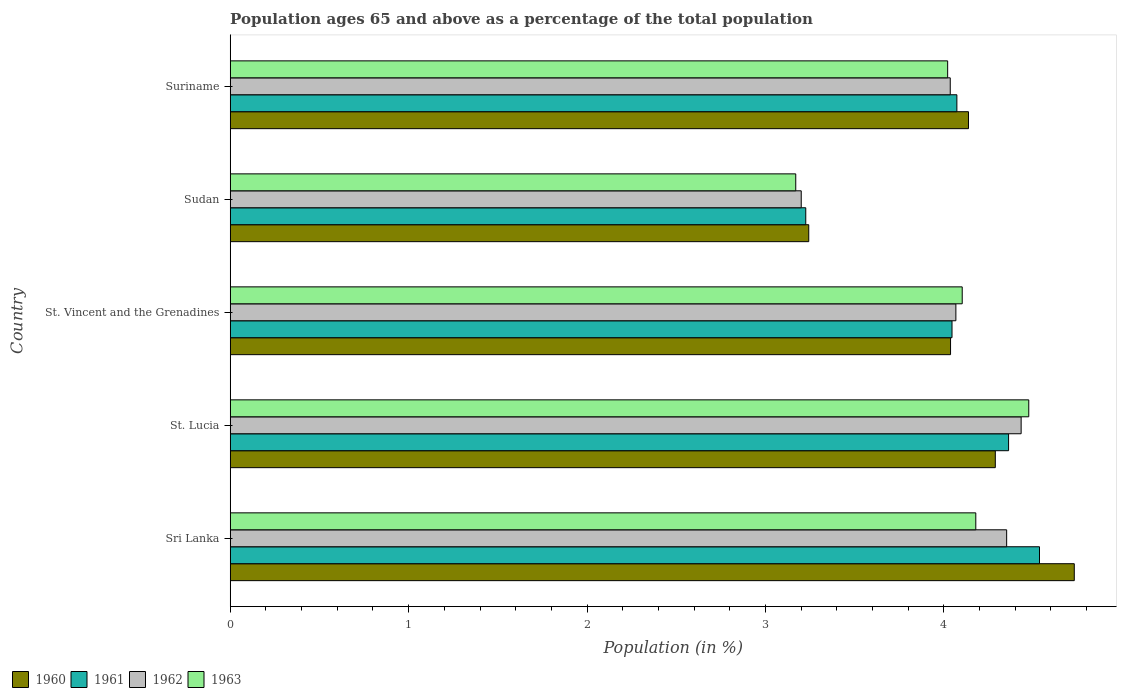Are the number of bars per tick equal to the number of legend labels?
Offer a very short reply. Yes. How many bars are there on the 5th tick from the bottom?
Keep it short and to the point. 4. What is the label of the 4th group of bars from the top?
Provide a short and direct response. St. Lucia. In how many cases, is the number of bars for a given country not equal to the number of legend labels?
Your response must be concise. 0. What is the percentage of the population ages 65 and above in 1963 in Sri Lanka?
Offer a very short reply. 4.18. Across all countries, what is the maximum percentage of the population ages 65 and above in 1962?
Ensure brevity in your answer.  4.43. Across all countries, what is the minimum percentage of the population ages 65 and above in 1961?
Provide a short and direct response. 3.23. In which country was the percentage of the population ages 65 and above in 1960 maximum?
Provide a short and direct response. Sri Lanka. In which country was the percentage of the population ages 65 and above in 1963 minimum?
Offer a very short reply. Sudan. What is the total percentage of the population ages 65 and above in 1960 in the graph?
Your answer should be very brief. 20.44. What is the difference between the percentage of the population ages 65 and above in 1962 in Sri Lanka and that in St. Lucia?
Offer a very short reply. -0.08. What is the difference between the percentage of the population ages 65 and above in 1962 in St. Vincent and the Grenadines and the percentage of the population ages 65 and above in 1961 in Sri Lanka?
Provide a succinct answer. -0.47. What is the average percentage of the population ages 65 and above in 1962 per country?
Offer a very short reply. 4.02. What is the difference between the percentage of the population ages 65 and above in 1961 and percentage of the population ages 65 and above in 1963 in Sudan?
Offer a terse response. 0.06. What is the ratio of the percentage of the population ages 65 and above in 1960 in St. Vincent and the Grenadines to that in Suriname?
Make the answer very short. 0.98. Is the difference between the percentage of the population ages 65 and above in 1961 in St. Lucia and Sudan greater than the difference between the percentage of the population ages 65 and above in 1963 in St. Lucia and Sudan?
Provide a succinct answer. No. What is the difference between the highest and the second highest percentage of the population ages 65 and above in 1962?
Your answer should be very brief. 0.08. What is the difference between the highest and the lowest percentage of the population ages 65 and above in 1961?
Ensure brevity in your answer.  1.31. In how many countries, is the percentage of the population ages 65 and above in 1961 greater than the average percentage of the population ages 65 and above in 1961 taken over all countries?
Your answer should be very brief. 3. Is the sum of the percentage of the population ages 65 and above in 1962 in St. Vincent and the Grenadines and Suriname greater than the maximum percentage of the population ages 65 and above in 1963 across all countries?
Provide a succinct answer. Yes. What does the 1st bar from the bottom in Suriname represents?
Your answer should be very brief. 1960. How many countries are there in the graph?
Keep it short and to the point. 5. What is the difference between two consecutive major ticks on the X-axis?
Your response must be concise. 1. Are the values on the major ticks of X-axis written in scientific E-notation?
Your answer should be compact. No. Does the graph contain any zero values?
Provide a short and direct response. No. Does the graph contain grids?
Keep it short and to the point. No. What is the title of the graph?
Your answer should be compact. Population ages 65 and above as a percentage of the total population. What is the label or title of the X-axis?
Your answer should be compact. Population (in %). What is the label or title of the Y-axis?
Provide a succinct answer. Country. What is the Population (in %) in 1960 in Sri Lanka?
Make the answer very short. 4.73. What is the Population (in %) in 1961 in Sri Lanka?
Provide a succinct answer. 4.54. What is the Population (in %) of 1962 in Sri Lanka?
Give a very brief answer. 4.35. What is the Population (in %) in 1963 in Sri Lanka?
Make the answer very short. 4.18. What is the Population (in %) in 1960 in St. Lucia?
Offer a terse response. 4.29. What is the Population (in %) in 1961 in St. Lucia?
Give a very brief answer. 4.36. What is the Population (in %) of 1962 in St. Lucia?
Provide a succinct answer. 4.43. What is the Population (in %) of 1963 in St. Lucia?
Your answer should be very brief. 4.48. What is the Population (in %) of 1960 in St. Vincent and the Grenadines?
Provide a short and direct response. 4.04. What is the Population (in %) of 1961 in St. Vincent and the Grenadines?
Provide a short and direct response. 4.05. What is the Population (in %) in 1962 in St. Vincent and the Grenadines?
Provide a succinct answer. 4.07. What is the Population (in %) of 1963 in St. Vincent and the Grenadines?
Your response must be concise. 4.1. What is the Population (in %) in 1960 in Sudan?
Offer a terse response. 3.24. What is the Population (in %) in 1961 in Sudan?
Ensure brevity in your answer.  3.23. What is the Population (in %) in 1962 in Sudan?
Ensure brevity in your answer.  3.2. What is the Population (in %) of 1963 in Sudan?
Your answer should be compact. 3.17. What is the Population (in %) of 1960 in Suriname?
Give a very brief answer. 4.14. What is the Population (in %) of 1961 in Suriname?
Keep it short and to the point. 4.07. What is the Population (in %) of 1962 in Suriname?
Give a very brief answer. 4.04. What is the Population (in %) of 1963 in Suriname?
Your answer should be very brief. 4.02. Across all countries, what is the maximum Population (in %) in 1960?
Offer a terse response. 4.73. Across all countries, what is the maximum Population (in %) in 1961?
Your answer should be compact. 4.54. Across all countries, what is the maximum Population (in %) of 1962?
Provide a succinct answer. 4.43. Across all countries, what is the maximum Population (in %) in 1963?
Keep it short and to the point. 4.48. Across all countries, what is the minimum Population (in %) of 1960?
Provide a short and direct response. 3.24. Across all countries, what is the minimum Population (in %) in 1961?
Your answer should be compact. 3.23. Across all countries, what is the minimum Population (in %) in 1962?
Provide a succinct answer. 3.2. Across all countries, what is the minimum Population (in %) of 1963?
Give a very brief answer. 3.17. What is the total Population (in %) in 1960 in the graph?
Ensure brevity in your answer.  20.44. What is the total Population (in %) in 1961 in the graph?
Make the answer very short. 20.24. What is the total Population (in %) of 1962 in the graph?
Make the answer very short. 20.09. What is the total Population (in %) in 1963 in the graph?
Provide a short and direct response. 19.95. What is the difference between the Population (in %) in 1960 in Sri Lanka and that in St. Lucia?
Your answer should be very brief. 0.44. What is the difference between the Population (in %) in 1961 in Sri Lanka and that in St. Lucia?
Give a very brief answer. 0.17. What is the difference between the Population (in %) in 1962 in Sri Lanka and that in St. Lucia?
Your answer should be very brief. -0.08. What is the difference between the Population (in %) of 1963 in Sri Lanka and that in St. Lucia?
Your response must be concise. -0.3. What is the difference between the Population (in %) in 1960 in Sri Lanka and that in St. Vincent and the Grenadines?
Offer a terse response. 0.69. What is the difference between the Population (in %) in 1961 in Sri Lanka and that in St. Vincent and the Grenadines?
Offer a terse response. 0.49. What is the difference between the Population (in %) in 1962 in Sri Lanka and that in St. Vincent and the Grenadines?
Ensure brevity in your answer.  0.28. What is the difference between the Population (in %) of 1963 in Sri Lanka and that in St. Vincent and the Grenadines?
Offer a terse response. 0.08. What is the difference between the Population (in %) of 1960 in Sri Lanka and that in Sudan?
Offer a terse response. 1.49. What is the difference between the Population (in %) in 1961 in Sri Lanka and that in Sudan?
Make the answer very short. 1.31. What is the difference between the Population (in %) in 1962 in Sri Lanka and that in Sudan?
Ensure brevity in your answer.  1.15. What is the difference between the Population (in %) of 1963 in Sri Lanka and that in Sudan?
Keep it short and to the point. 1.01. What is the difference between the Population (in %) in 1960 in Sri Lanka and that in Suriname?
Your answer should be very brief. 0.59. What is the difference between the Population (in %) of 1961 in Sri Lanka and that in Suriname?
Provide a short and direct response. 0.46. What is the difference between the Population (in %) in 1962 in Sri Lanka and that in Suriname?
Keep it short and to the point. 0.32. What is the difference between the Population (in %) of 1963 in Sri Lanka and that in Suriname?
Your answer should be very brief. 0.16. What is the difference between the Population (in %) of 1960 in St. Lucia and that in St. Vincent and the Grenadines?
Provide a succinct answer. 0.25. What is the difference between the Population (in %) in 1961 in St. Lucia and that in St. Vincent and the Grenadines?
Provide a succinct answer. 0.32. What is the difference between the Population (in %) of 1962 in St. Lucia and that in St. Vincent and the Grenadines?
Your response must be concise. 0.37. What is the difference between the Population (in %) of 1963 in St. Lucia and that in St. Vincent and the Grenadines?
Keep it short and to the point. 0.37. What is the difference between the Population (in %) of 1960 in St. Lucia and that in Sudan?
Your answer should be very brief. 1.05. What is the difference between the Population (in %) in 1961 in St. Lucia and that in Sudan?
Your response must be concise. 1.14. What is the difference between the Population (in %) in 1962 in St. Lucia and that in Sudan?
Offer a terse response. 1.23. What is the difference between the Population (in %) of 1963 in St. Lucia and that in Sudan?
Offer a very short reply. 1.31. What is the difference between the Population (in %) in 1960 in St. Lucia and that in Suriname?
Your response must be concise. 0.15. What is the difference between the Population (in %) of 1961 in St. Lucia and that in Suriname?
Provide a succinct answer. 0.29. What is the difference between the Population (in %) of 1962 in St. Lucia and that in Suriname?
Your answer should be compact. 0.4. What is the difference between the Population (in %) of 1963 in St. Lucia and that in Suriname?
Provide a short and direct response. 0.45. What is the difference between the Population (in %) in 1960 in St. Vincent and the Grenadines and that in Sudan?
Ensure brevity in your answer.  0.79. What is the difference between the Population (in %) of 1961 in St. Vincent and the Grenadines and that in Sudan?
Offer a very short reply. 0.82. What is the difference between the Population (in %) of 1962 in St. Vincent and the Grenadines and that in Sudan?
Provide a short and direct response. 0.87. What is the difference between the Population (in %) of 1963 in St. Vincent and the Grenadines and that in Sudan?
Offer a very short reply. 0.93. What is the difference between the Population (in %) in 1960 in St. Vincent and the Grenadines and that in Suriname?
Offer a very short reply. -0.1. What is the difference between the Population (in %) in 1961 in St. Vincent and the Grenadines and that in Suriname?
Make the answer very short. -0.03. What is the difference between the Population (in %) in 1962 in St. Vincent and the Grenadines and that in Suriname?
Give a very brief answer. 0.03. What is the difference between the Population (in %) in 1963 in St. Vincent and the Grenadines and that in Suriname?
Your response must be concise. 0.08. What is the difference between the Population (in %) in 1960 in Sudan and that in Suriname?
Give a very brief answer. -0.9. What is the difference between the Population (in %) in 1961 in Sudan and that in Suriname?
Provide a succinct answer. -0.85. What is the difference between the Population (in %) in 1962 in Sudan and that in Suriname?
Your answer should be compact. -0.84. What is the difference between the Population (in %) of 1963 in Sudan and that in Suriname?
Your response must be concise. -0.85. What is the difference between the Population (in %) of 1960 in Sri Lanka and the Population (in %) of 1961 in St. Lucia?
Offer a terse response. 0.37. What is the difference between the Population (in %) of 1960 in Sri Lanka and the Population (in %) of 1962 in St. Lucia?
Provide a succinct answer. 0.3. What is the difference between the Population (in %) in 1960 in Sri Lanka and the Population (in %) in 1963 in St. Lucia?
Provide a short and direct response. 0.26. What is the difference between the Population (in %) in 1961 in Sri Lanka and the Population (in %) in 1962 in St. Lucia?
Your answer should be compact. 0.1. What is the difference between the Population (in %) of 1961 in Sri Lanka and the Population (in %) of 1963 in St. Lucia?
Your answer should be compact. 0.06. What is the difference between the Population (in %) in 1962 in Sri Lanka and the Population (in %) in 1963 in St. Lucia?
Make the answer very short. -0.12. What is the difference between the Population (in %) of 1960 in Sri Lanka and the Population (in %) of 1961 in St. Vincent and the Grenadines?
Your response must be concise. 0.69. What is the difference between the Population (in %) in 1960 in Sri Lanka and the Population (in %) in 1962 in St. Vincent and the Grenadines?
Provide a succinct answer. 0.66. What is the difference between the Population (in %) of 1960 in Sri Lanka and the Population (in %) of 1963 in St. Vincent and the Grenadines?
Provide a succinct answer. 0.63. What is the difference between the Population (in %) in 1961 in Sri Lanka and the Population (in %) in 1962 in St. Vincent and the Grenadines?
Ensure brevity in your answer.  0.47. What is the difference between the Population (in %) in 1961 in Sri Lanka and the Population (in %) in 1963 in St. Vincent and the Grenadines?
Offer a very short reply. 0.43. What is the difference between the Population (in %) in 1962 in Sri Lanka and the Population (in %) in 1963 in St. Vincent and the Grenadines?
Offer a very short reply. 0.25. What is the difference between the Population (in %) in 1960 in Sri Lanka and the Population (in %) in 1961 in Sudan?
Provide a short and direct response. 1.5. What is the difference between the Population (in %) in 1960 in Sri Lanka and the Population (in %) in 1962 in Sudan?
Make the answer very short. 1.53. What is the difference between the Population (in %) in 1960 in Sri Lanka and the Population (in %) in 1963 in Sudan?
Provide a succinct answer. 1.56. What is the difference between the Population (in %) of 1961 in Sri Lanka and the Population (in %) of 1962 in Sudan?
Provide a succinct answer. 1.34. What is the difference between the Population (in %) of 1961 in Sri Lanka and the Population (in %) of 1963 in Sudan?
Your response must be concise. 1.37. What is the difference between the Population (in %) in 1962 in Sri Lanka and the Population (in %) in 1963 in Sudan?
Your response must be concise. 1.18. What is the difference between the Population (in %) of 1960 in Sri Lanka and the Population (in %) of 1961 in Suriname?
Make the answer very short. 0.66. What is the difference between the Population (in %) in 1960 in Sri Lanka and the Population (in %) in 1962 in Suriname?
Your answer should be compact. 0.7. What is the difference between the Population (in %) of 1960 in Sri Lanka and the Population (in %) of 1963 in Suriname?
Your answer should be very brief. 0.71. What is the difference between the Population (in %) in 1961 in Sri Lanka and the Population (in %) in 1962 in Suriname?
Make the answer very short. 0.5. What is the difference between the Population (in %) of 1961 in Sri Lanka and the Population (in %) of 1963 in Suriname?
Give a very brief answer. 0.51. What is the difference between the Population (in %) of 1962 in Sri Lanka and the Population (in %) of 1963 in Suriname?
Your answer should be compact. 0.33. What is the difference between the Population (in %) of 1960 in St. Lucia and the Population (in %) of 1961 in St. Vincent and the Grenadines?
Make the answer very short. 0.24. What is the difference between the Population (in %) in 1960 in St. Lucia and the Population (in %) in 1962 in St. Vincent and the Grenadines?
Provide a short and direct response. 0.22. What is the difference between the Population (in %) of 1960 in St. Lucia and the Population (in %) of 1963 in St. Vincent and the Grenadines?
Keep it short and to the point. 0.19. What is the difference between the Population (in %) in 1961 in St. Lucia and the Population (in %) in 1962 in St. Vincent and the Grenadines?
Your answer should be very brief. 0.3. What is the difference between the Population (in %) in 1961 in St. Lucia and the Population (in %) in 1963 in St. Vincent and the Grenadines?
Your answer should be compact. 0.26. What is the difference between the Population (in %) in 1962 in St. Lucia and the Population (in %) in 1963 in St. Vincent and the Grenadines?
Your answer should be compact. 0.33. What is the difference between the Population (in %) in 1960 in St. Lucia and the Population (in %) in 1961 in Sudan?
Your answer should be very brief. 1.06. What is the difference between the Population (in %) in 1960 in St. Lucia and the Population (in %) in 1962 in Sudan?
Offer a terse response. 1.09. What is the difference between the Population (in %) of 1960 in St. Lucia and the Population (in %) of 1963 in Sudan?
Provide a short and direct response. 1.12. What is the difference between the Population (in %) in 1961 in St. Lucia and the Population (in %) in 1962 in Sudan?
Offer a terse response. 1.16. What is the difference between the Population (in %) in 1961 in St. Lucia and the Population (in %) in 1963 in Sudan?
Your response must be concise. 1.19. What is the difference between the Population (in %) of 1962 in St. Lucia and the Population (in %) of 1963 in Sudan?
Your answer should be compact. 1.26. What is the difference between the Population (in %) of 1960 in St. Lucia and the Population (in %) of 1961 in Suriname?
Keep it short and to the point. 0.22. What is the difference between the Population (in %) of 1960 in St. Lucia and the Population (in %) of 1962 in Suriname?
Your answer should be compact. 0.25. What is the difference between the Population (in %) of 1960 in St. Lucia and the Population (in %) of 1963 in Suriname?
Ensure brevity in your answer.  0.27. What is the difference between the Population (in %) in 1961 in St. Lucia and the Population (in %) in 1962 in Suriname?
Your answer should be very brief. 0.33. What is the difference between the Population (in %) in 1961 in St. Lucia and the Population (in %) in 1963 in Suriname?
Provide a succinct answer. 0.34. What is the difference between the Population (in %) in 1962 in St. Lucia and the Population (in %) in 1963 in Suriname?
Keep it short and to the point. 0.41. What is the difference between the Population (in %) of 1960 in St. Vincent and the Grenadines and the Population (in %) of 1961 in Sudan?
Offer a terse response. 0.81. What is the difference between the Population (in %) of 1960 in St. Vincent and the Grenadines and the Population (in %) of 1962 in Sudan?
Provide a succinct answer. 0.84. What is the difference between the Population (in %) in 1960 in St. Vincent and the Grenadines and the Population (in %) in 1963 in Sudan?
Make the answer very short. 0.87. What is the difference between the Population (in %) of 1961 in St. Vincent and the Grenadines and the Population (in %) of 1962 in Sudan?
Make the answer very short. 0.84. What is the difference between the Population (in %) of 1961 in St. Vincent and the Grenadines and the Population (in %) of 1963 in Sudan?
Your answer should be very brief. 0.88. What is the difference between the Population (in %) of 1962 in St. Vincent and the Grenadines and the Population (in %) of 1963 in Sudan?
Your answer should be compact. 0.9. What is the difference between the Population (in %) of 1960 in St. Vincent and the Grenadines and the Population (in %) of 1961 in Suriname?
Offer a very short reply. -0.04. What is the difference between the Population (in %) in 1960 in St. Vincent and the Grenadines and the Population (in %) in 1962 in Suriname?
Offer a very short reply. 0. What is the difference between the Population (in %) in 1960 in St. Vincent and the Grenadines and the Population (in %) in 1963 in Suriname?
Your answer should be very brief. 0.02. What is the difference between the Population (in %) of 1961 in St. Vincent and the Grenadines and the Population (in %) of 1962 in Suriname?
Give a very brief answer. 0.01. What is the difference between the Population (in %) in 1961 in St. Vincent and the Grenadines and the Population (in %) in 1963 in Suriname?
Keep it short and to the point. 0.02. What is the difference between the Population (in %) in 1962 in St. Vincent and the Grenadines and the Population (in %) in 1963 in Suriname?
Ensure brevity in your answer.  0.05. What is the difference between the Population (in %) in 1960 in Sudan and the Population (in %) in 1961 in Suriname?
Make the answer very short. -0.83. What is the difference between the Population (in %) in 1960 in Sudan and the Population (in %) in 1962 in Suriname?
Your response must be concise. -0.79. What is the difference between the Population (in %) of 1960 in Sudan and the Population (in %) of 1963 in Suriname?
Give a very brief answer. -0.78. What is the difference between the Population (in %) in 1961 in Sudan and the Population (in %) in 1962 in Suriname?
Your answer should be compact. -0.81. What is the difference between the Population (in %) in 1961 in Sudan and the Population (in %) in 1963 in Suriname?
Keep it short and to the point. -0.8. What is the difference between the Population (in %) in 1962 in Sudan and the Population (in %) in 1963 in Suriname?
Provide a succinct answer. -0.82. What is the average Population (in %) in 1960 per country?
Provide a succinct answer. 4.09. What is the average Population (in %) in 1961 per country?
Offer a very short reply. 4.05. What is the average Population (in %) in 1962 per country?
Offer a very short reply. 4.02. What is the average Population (in %) of 1963 per country?
Make the answer very short. 3.99. What is the difference between the Population (in %) in 1960 and Population (in %) in 1961 in Sri Lanka?
Provide a succinct answer. 0.19. What is the difference between the Population (in %) of 1960 and Population (in %) of 1962 in Sri Lanka?
Offer a terse response. 0.38. What is the difference between the Population (in %) in 1960 and Population (in %) in 1963 in Sri Lanka?
Ensure brevity in your answer.  0.55. What is the difference between the Population (in %) of 1961 and Population (in %) of 1962 in Sri Lanka?
Your answer should be compact. 0.18. What is the difference between the Population (in %) of 1961 and Population (in %) of 1963 in Sri Lanka?
Your answer should be compact. 0.36. What is the difference between the Population (in %) in 1962 and Population (in %) in 1963 in Sri Lanka?
Your response must be concise. 0.17. What is the difference between the Population (in %) in 1960 and Population (in %) in 1961 in St. Lucia?
Your answer should be very brief. -0.07. What is the difference between the Population (in %) in 1960 and Population (in %) in 1962 in St. Lucia?
Your response must be concise. -0.14. What is the difference between the Population (in %) in 1960 and Population (in %) in 1963 in St. Lucia?
Give a very brief answer. -0.19. What is the difference between the Population (in %) of 1961 and Population (in %) of 1962 in St. Lucia?
Your response must be concise. -0.07. What is the difference between the Population (in %) in 1961 and Population (in %) in 1963 in St. Lucia?
Your response must be concise. -0.11. What is the difference between the Population (in %) of 1962 and Population (in %) of 1963 in St. Lucia?
Make the answer very short. -0.04. What is the difference between the Population (in %) of 1960 and Population (in %) of 1961 in St. Vincent and the Grenadines?
Ensure brevity in your answer.  -0.01. What is the difference between the Population (in %) in 1960 and Population (in %) in 1962 in St. Vincent and the Grenadines?
Keep it short and to the point. -0.03. What is the difference between the Population (in %) of 1960 and Population (in %) of 1963 in St. Vincent and the Grenadines?
Give a very brief answer. -0.07. What is the difference between the Population (in %) in 1961 and Population (in %) in 1962 in St. Vincent and the Grenadines?
Ensure brevity in your answer.  -0.02. What is the difference between the Population (in %) in 1961 and Population (in %) in 1963 in St. Vincent and the Grenadines?
Offer a terse response. -0.06. What is the difference between the Population (in %) of 1962 and Population (in %) of 1963 in St. Vincent and the Grenadines?
Your answer should be compact. -0.04. What is the difference between the Population (in %) in 1960 and Population (in %) in 1961 in Sudan?
Provide a short and direct response. 0.02. What is the difference between the Population (in %) of 1960 and Population (in %) of 1962 in Sudan?
Offer a terse response. 0.04. What is the difference between the Population (in %) in 1960 and Population (in %) in 1963 in Sudan?
Make the answer very short. 0.07. What is the difference between the Population (in %) of 1961 and Population (in %) of 1962 in Sudan?
Provide a succinct answer. 0.03. What is the difference between the Population (in %) in 1961 and Population (in %) in 1963 in Sudan?
Ensure brevity in your answer.  0.06. What is the difference between the Population (in %) of 1962 and Population (in %) of 1963 in Sudan?
Make the answer very short. 0.03. What is the difference between the Population (in %) in 1960 and Population (in %) in 1961 in Suriname?
Provide a succinct answer. 0.07. What is the difference between the Population (in %) of 1960 and Population (in %) of 1962 in Suriname?
Your answer should be compact. 0.1. What is the difference between the Population (in %) of 1960 and Population (in %) of 1963 in Suriname?
Your answer should be compact. 0.12. What is the difference between the Population (in %) in 1961 and Population (in %) in 1962 in Suriname?
Provide a succinct answer. 0.04. What is the difference between the Population (in %) of 1961 and Population (in %) of 1963 in Suriname?
Keep it short and to the point. 0.05. What is the difference between the Population (in %) in 1962 and Population (in %) in 1963 in Suriname?
Provide a succinct answer. 0.01. What is the ratio of the Population (in %) of 1960 in Sri Lanka to that in St. Lucia?
Your answer should be very brief. 1.1. What is the ratio of the Population (in %) of 1961 in Sri Lanka to that in St. Lucia?
Offer a very short reply. 1.04. What is the ratio of the Population (in %) in 1962 in Sri Lanka to that in St. Lucia?
Provide a succinct answer. 0.98. What is the ratio of the Population (in %) in 1963 in Sri Lanka to that in St. Lucia?
Your answer should be very brief. 0.93. What is the ratio of the Population (in %) of 1960 in Sri Lanka to that in St. Vincent and the Grenadines?
Offer a terse response. 1.17. What is the ratio of the Population (in %) in 1961 in Sri Lanka to that in St. Vincent and the Grenadines?
Give a very brief answer. 1.12. What is the ratio of the Population (in %) of 1962 in Sri Lanka to that in St. Vincent and the Grenadines?
Your answer should be very brief. 1.07. What is the ratio of the Population (in %) of 1963 in Sri Lanka to that in St. Vincent and the Grenadines?
Keep it short and to the point. 1.02. What is the ratio of the Population (in %) of 1960 in Sri Lanka to that in Sudan?
Offer a very short reply. 1.46. What is the ratio of the Population (in %) in 1961 in Sri Lanka to that in Sudan?
Give a very brief answer. 1.41. What is the ratio of the Population (in %) in 1962 in Sri Lanka to that in Sudan?
Your answer should be compact. 1.36. What is the ratio of the Population (in %) of 1963 in Sri Lanka to that in Sudan?
Offer a terse response. 1.32. What is the ratio of the Population (in %) in 1960 in Sri Lanka to that in Suriname?
Offer a terse response. 1.14. What is the ratio of the Population (in %) of 1961 in Sri Lanka to that in Suriname?
Keep it short and to the point. 1.11. What is the ratio of the Population (in %) in 1962 in Sri Lanka to that in Suriname?
Keep it short and to the point. 1.08. What is the ratio of the Population (in %) of 1963 in Sri Lanka to that in Suriname?
Your answer should be very brief. 1.04. What is the ratio of the Population (in %) in 1960 in St. Lucia to that in St. Vincent and the Grenadines?
Ensure brevity in your answer.  1.06. What is the ratio of the Population (in %) in 1961 in St. Lucia to that in St. Vincent and the Grenadines?
Provide a succinct answer. 1.08. What is the ratio of the Population (in %) in 1962 in St. Lucia to that in St. Vincent and the Grenadines?
Make the answer very short. 1.09. What is the ratio of the Population (in %) in 1960 in St. Lucia to that in Sudan?
Offer a terse response. 1.32. What is the ratio of the Population (in %) of 1961 in St. Lucia to that in Sudan?
Give a very brief answer. 1.35. What is the ratio of the Population (in %) of 1962 in St. Lucia to that in Sudan?
Your response must be concise. 1.39. What is the ratio of the Population (in %) in 1963 in St. Lucia to that in Sudan?
Your answer should be very brief. 1.41. What is the ratio of the Population (in %) of 1960 in St. Lucia to that in Suriname?
Your answer should be compact. 1.04. What is the ratio of the Population (in %) of 1961 in St. Lucia to that in Suriname?
Your response must be concise. 1.07. What is the ratio of the Population (in %) of 1962 in St. Lucia to that in Suriname?
Offer a terse response. 1.1. What is the ratio of the Population (in %) in 1963 in St. Lucia to that in Suriname?
Give a very brief answer. 1.11. What is the ratio of the Population (in %) of 1960 in St. Vincent and the Grenadines to that in Sudan?
Ensure brevity in your answer.  1.25. What is the ratio of the Population (in %) in 1961 in St. Vincent and the Grenadines to that in Sudan?
Ensure brevity in your answer.  1.25. What is the ratio of the Population (in %) in 1962 in St. Vincent and the Grenadines to that in Sudan?
Provide a short and direct response. 1.27. What is the ratio of the Population (in %) of 1963 in St. Vincent and the Grenadines to that in Sudan?
Offer a terse response. 1.29. What is the ratio of the Population (in %) in 1960 in St. Vincent and the Grenadines to that in Suriname?
Offer a terse response. 0.98. What is the ratio of the Population (in %) of 1961 in St. Vincent and the Grenadines to that in Suriname?
Give a very brief answer. 0.99. What is the ratio of the Population (in %) in 1963 in St. Vincent and the Grenadines to that in Suriname?
Offer a very short reply. 1.02. What is the ratio of the Population (in %) in 1960 in Sudan to that in Suriname?
Your response must be concise. 0.78. What is the ratio of the Population (in %) in 1961 in Sudan to that in Suriname?
Make the answer very short. 0.79. What is the ratio of the Population (in %) in 1962 in Sudan to that in Suriname?
Your response must be concise. 0.79. What is the ratio of the Population (in %) in 1963 in Sudan to that in Suriname?
Your answer should be very brief. 0.79. What is the difference between the highest and the second highest Population (in %) in 1960?
Provide a succinct answer. 0.44. What is the difference between the highest and the second highest Population (in %) in 1961?
Offer a very short reply. 0.17. What is the difference between the highest and the second highest Population (in %) in 1962?
Give a very brief answer. 0.08. What is the difference between the highest and the second highest Population (in %) of 1963?
Offer a very short reply. 0.3. What is the difference between the highest and the lowest Population (in %) in 1960?
Keep it short and to the point. 1.49. What is the difference between the highest and the lowest Population (in %) of 1961?
Your answer should be very brief. 1.31. What is the difference between the highest and the lowest Population (in %) of 1962?
Ensure brevity in your answer.  1.23. What is the difference between the highest and the lowest Population (in %) of 1963?
Keep it short and to the point. 1.31. 